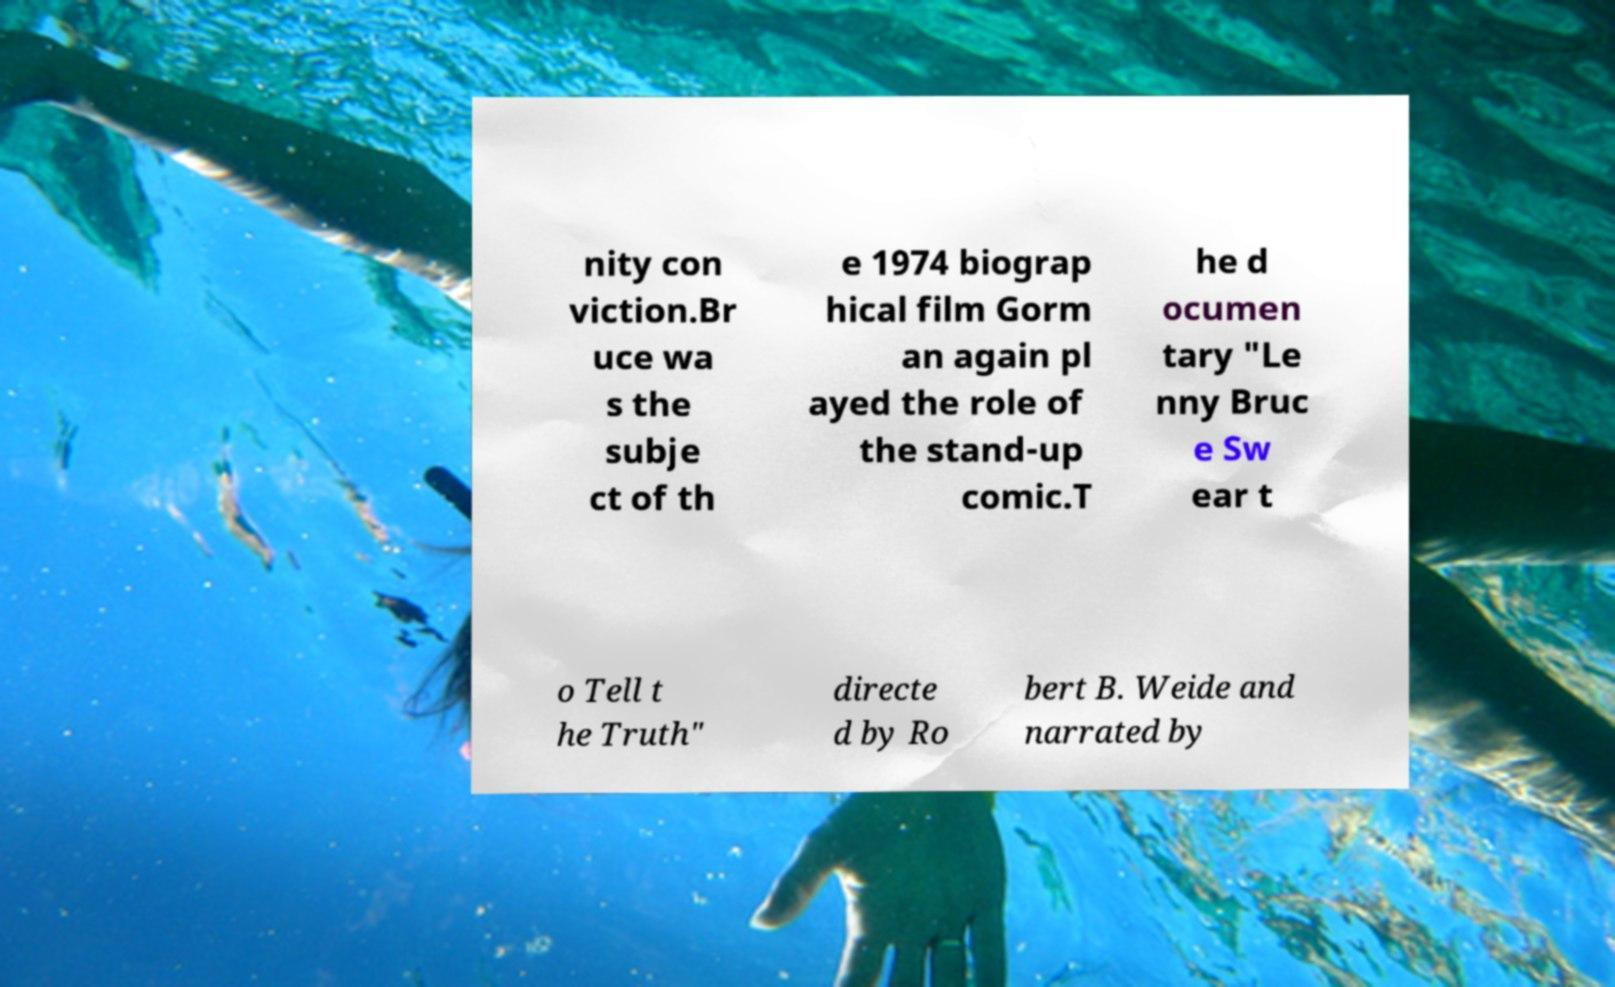Please read and relay the text visible in this image. What does it say? nity con viction.Br uce wa s the subje ct of th e 1974 biograp hical film Gorm an again pl ayed the role of the stand-up comic.T he d ocumen tary "Le nny Bruc e Sw ear t o Tell t he Truth" directe d by Ro bert B. Weide and narrated by 